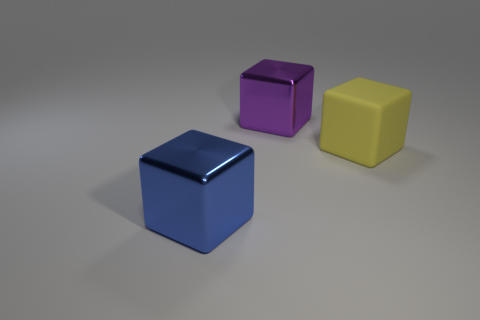How does the lighting in the image affect the perception of the blocks? The lighting in the image is soft and diffused, coming from the upper left corner, casting subtle shadows opposite it. This gentle illumination highlights the shiny textures of the blocks and enhances the dimensionality and color vibrancy, giving us a clear sense of the blocks' forms and surfaces. 